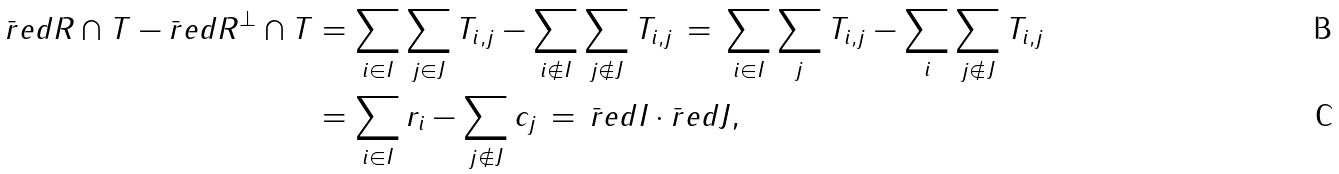Convert formula to latex. <formula><loc_0><loc_0><loc_500><loc_500>\bar { r } e d { R \cap T } - \bar { r } e d { R ^ { \perp } \cap T } & = \sum _ { i \in I } \sum _ { j \in J } T _ { i , j } - \sum _ { i \notin I } \sum _ { j \notin J } T _ { i , j } \, = \, \sum _ { i \in I } \sum _ { j } T _ { i , j } - \sum _ { i } \sum _ { j \notin J } T _ { i , j } \\ & = \sum _ { i \in I } r _ { i } - \sum _ { j \notin J } c _ { j } \, = \, \bar { r } e d { I } \cdot \bar { r } e d { J } ,</formula> 